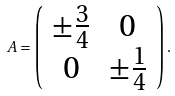Convert formula to latex. <formula><loc_0><loc_0><loc_500><loc_500>A = \left ( \begin{array} { c c } \pm \frac { 3 } { 4 } & 0 \\ 0 & \pm \frac { 1 } { 4 } \end{array} \right ) .</formula> 